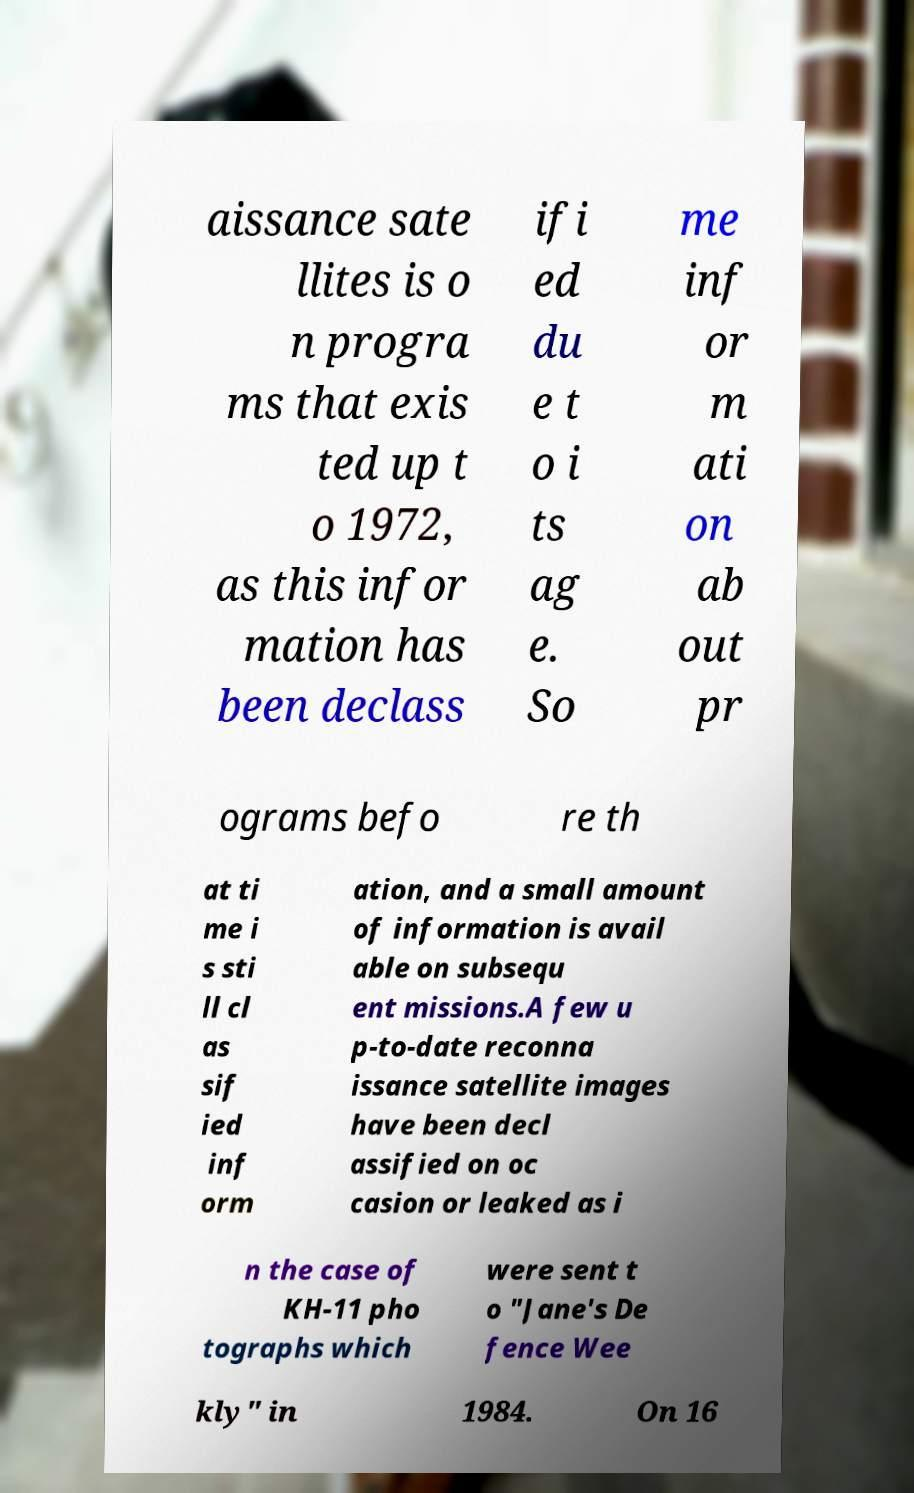Please read and relay the text visible in this image. What does it say? aissance sate llites is o n progra ms that exis ted up t o 1972, as this infor mation has been declass ifi ed du e t o i ts ag e. So me inf or m ati on ab out pr ograms befo re th at ti me i s sti ll cl as sif ied inf orm ation, and a small amount of information is avail able on subsequ ent missions.A few u p-to-date reconna issance satellite images have been decl assified on oc casion or leaked as i n the case of KH-11 pho tographs which were sent t o "Jane's De fence Wee kly" in 1984. On 16 